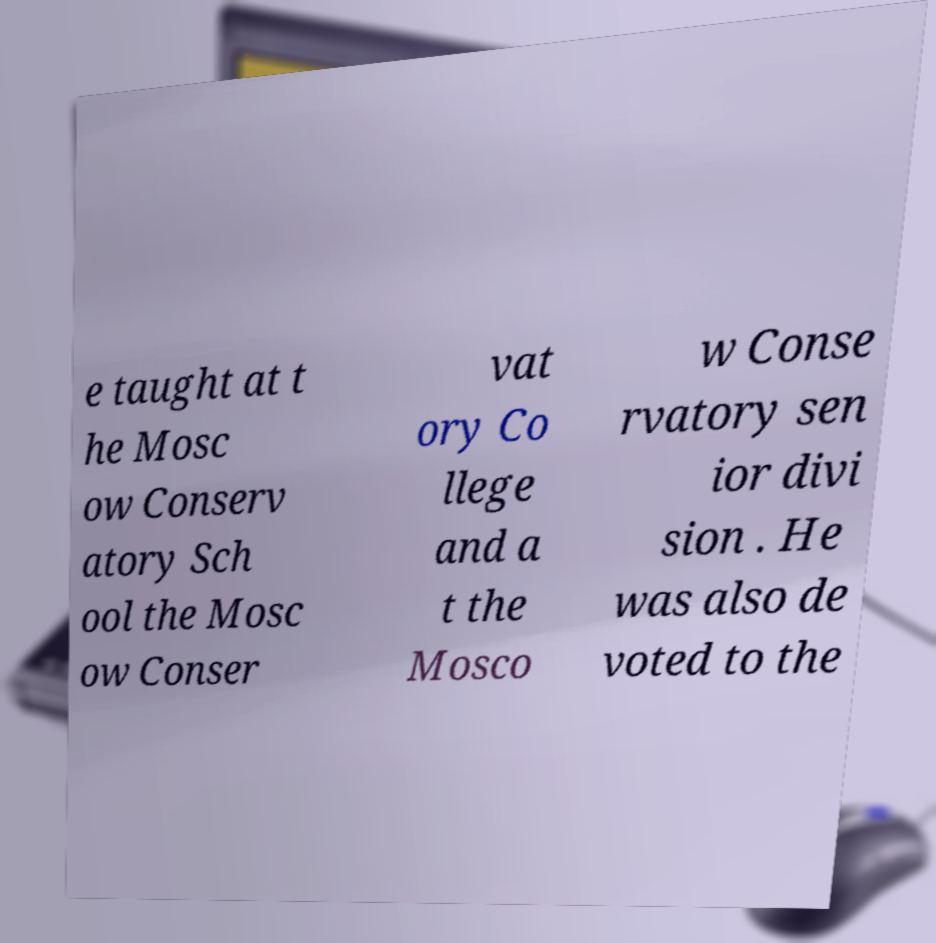Can you read and provide the text displayed in the image?This photo seems to have some interesting text. Can you extract and type it out for me? e taught at t he Mosc ow Conserv atory Sch ool the Mosc ow Conser vat ory Co llege and a t the Mosco w Conse rvatory sen ior divi sion . He was also de voted to the 